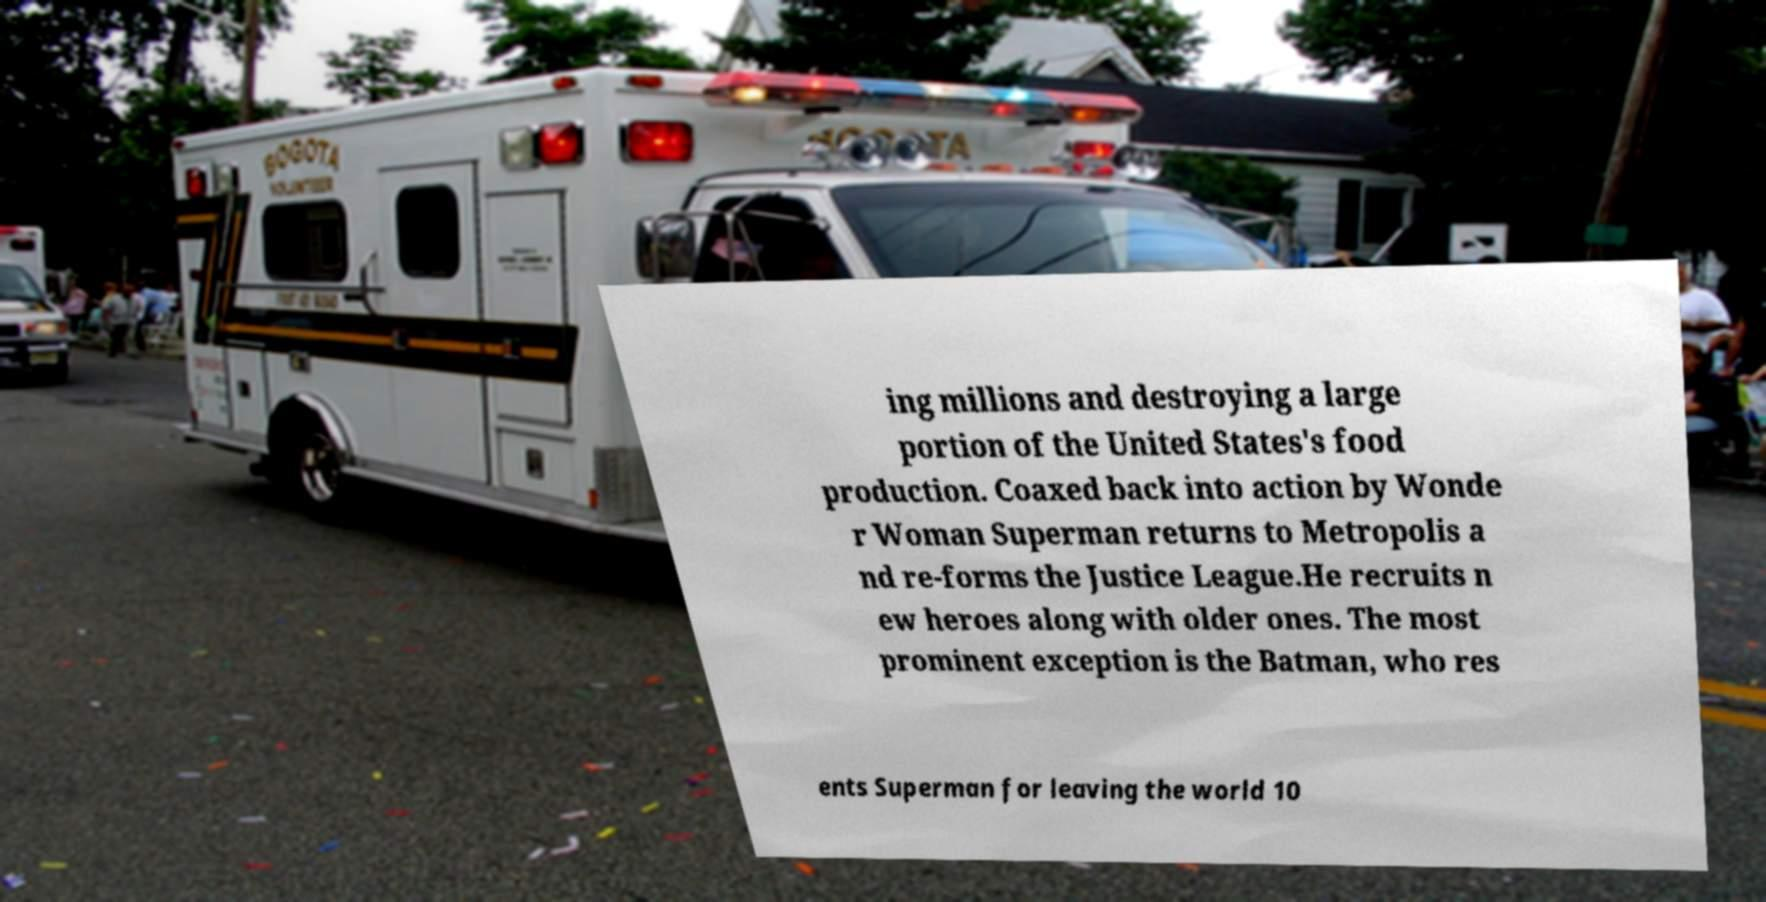Please identify and transcribe the text found in this image. ing millions and destroying a large portion of the United States's food production. Coaxed back into action by Wonde r Woman Superman returns to Metropolis a nd re-forms the Justice League.He recruits n ew heroes along with older ones. The most prominent exception is the Batman, who res ents Superman for leaving the world 10 